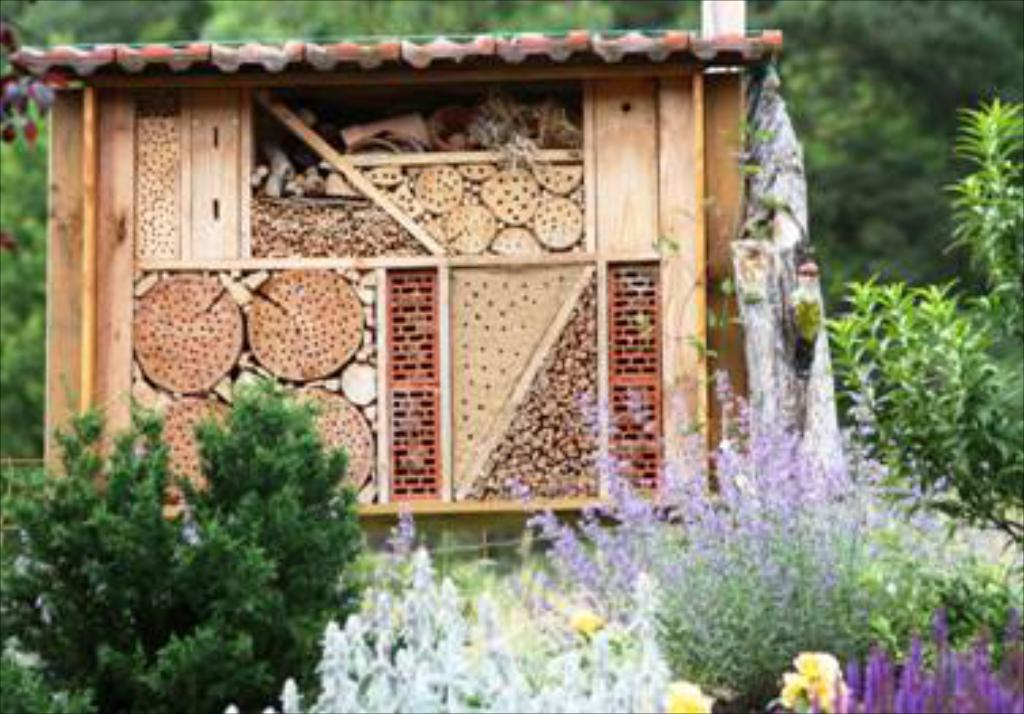What is the main structure in the center of the image? There is a shed in the center of the image. What can be seen in the background of the image? There are trees in the background of the image. What type of vegetation is present in the image? There are plants in the image. What news is being broadcasted from the shed in the image? There is no indication in the image that the shed is broadcasting any news. 